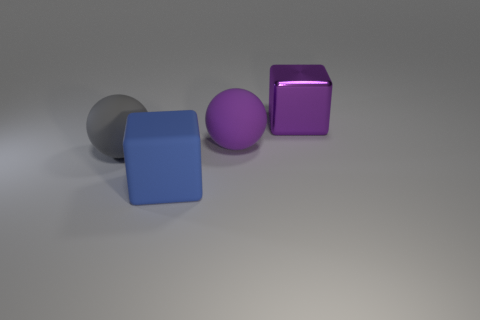Add 2 tiny purple metallic balls. How many objects exist? 6 Add 2 big green shiny balls. How many big green shiny balls exist? 2 Subtract 0 cyan blocks. How many objects are left? 4 Subtract all purple matte objects. Subtract all matte things. How many objects are left? 0 Add 3 matte blocks. How many matte blocks are left? 4 